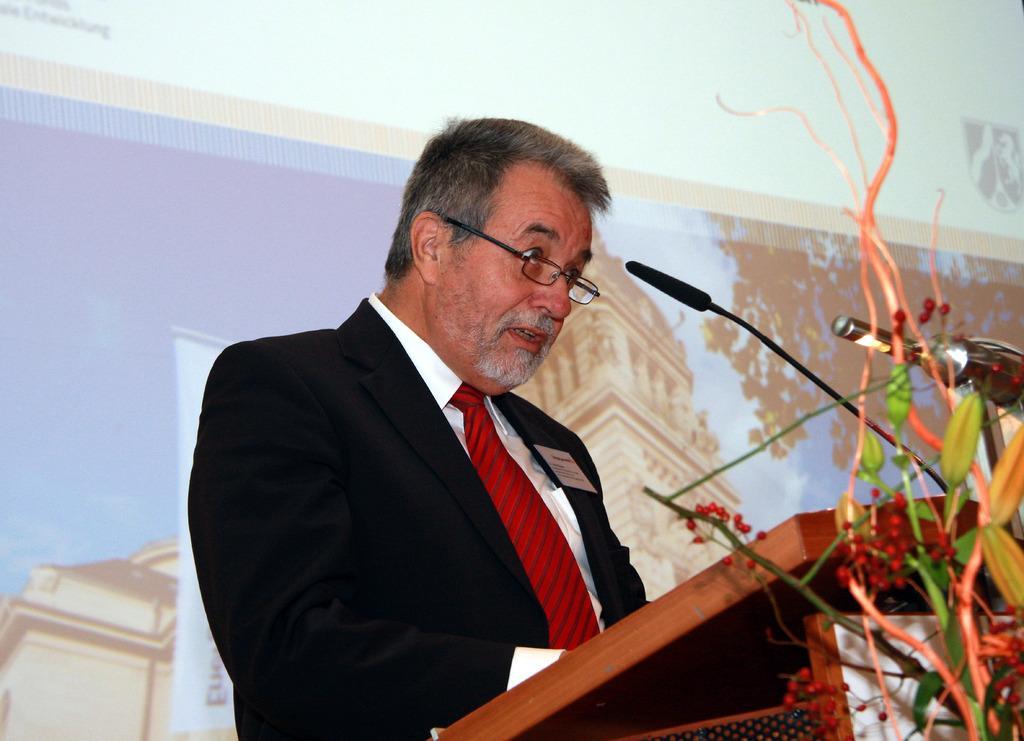In one or two sentences, can you explain what this image depicts? In this image I can see a man is standing in front of a podium. The man is wearing a black color coat, a shirt and a tie. On the podium I can see a microphone. In the background I can see projector screen. On the screen I can see buildings, tree and the sky. 